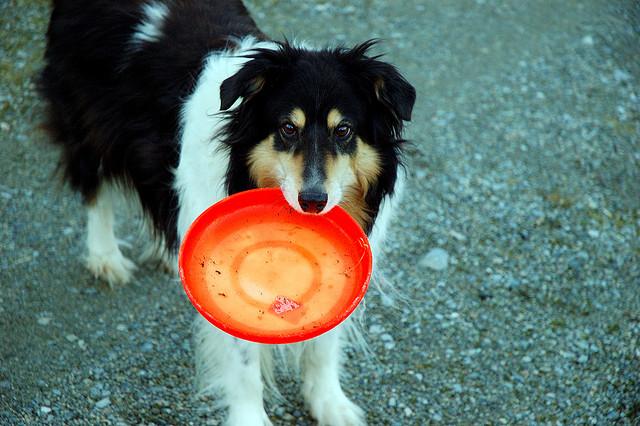Is this a grassy field?
Short answer required. No. What color is the frisbee?
Quick response, please. Red. What is the dog holding in its mouth?
Quick response, please. Frisbee. What type of dog is this?
Answer briefly. Collie. Does the dog want to eat the disk?
Answer briefly. No. 